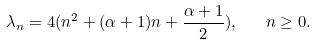Convert formula to latex. <formula><loc_0><loc_0><loc_500><loc_500>\lambda _ { n } = 4 ( n ^ { 2 } + ( \alpha + 1 ) n + \frac { \alpha + 1 } { 2 } ) , \quad n \geq 0 .</formula> 